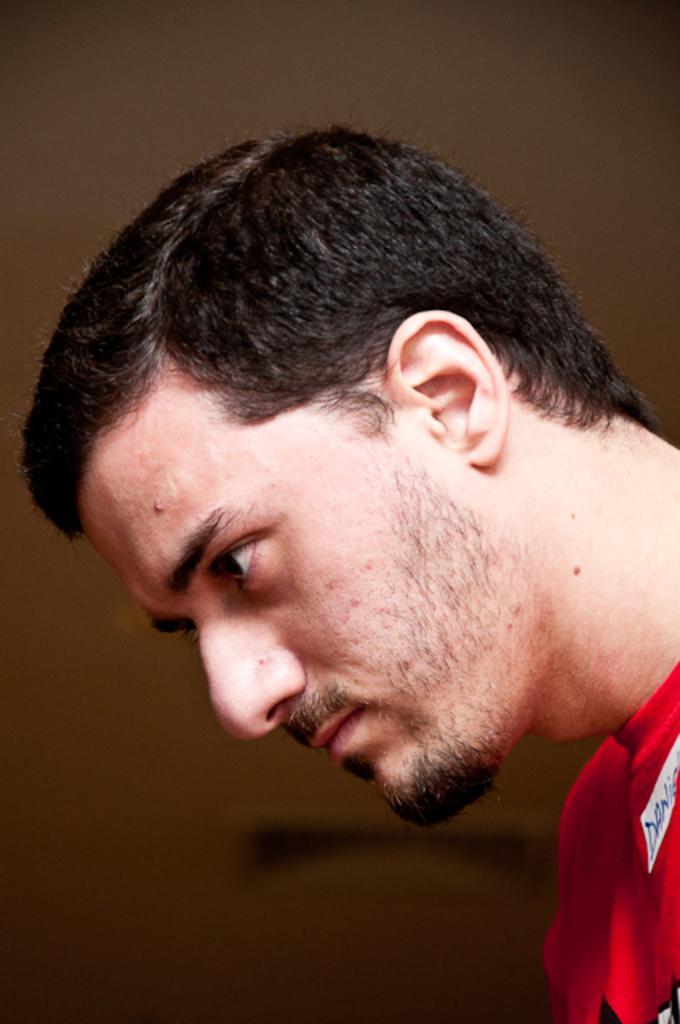Please provide a concise description of this image. In this image I can see the person is wearing red color dress. Background is in brown and black color. 